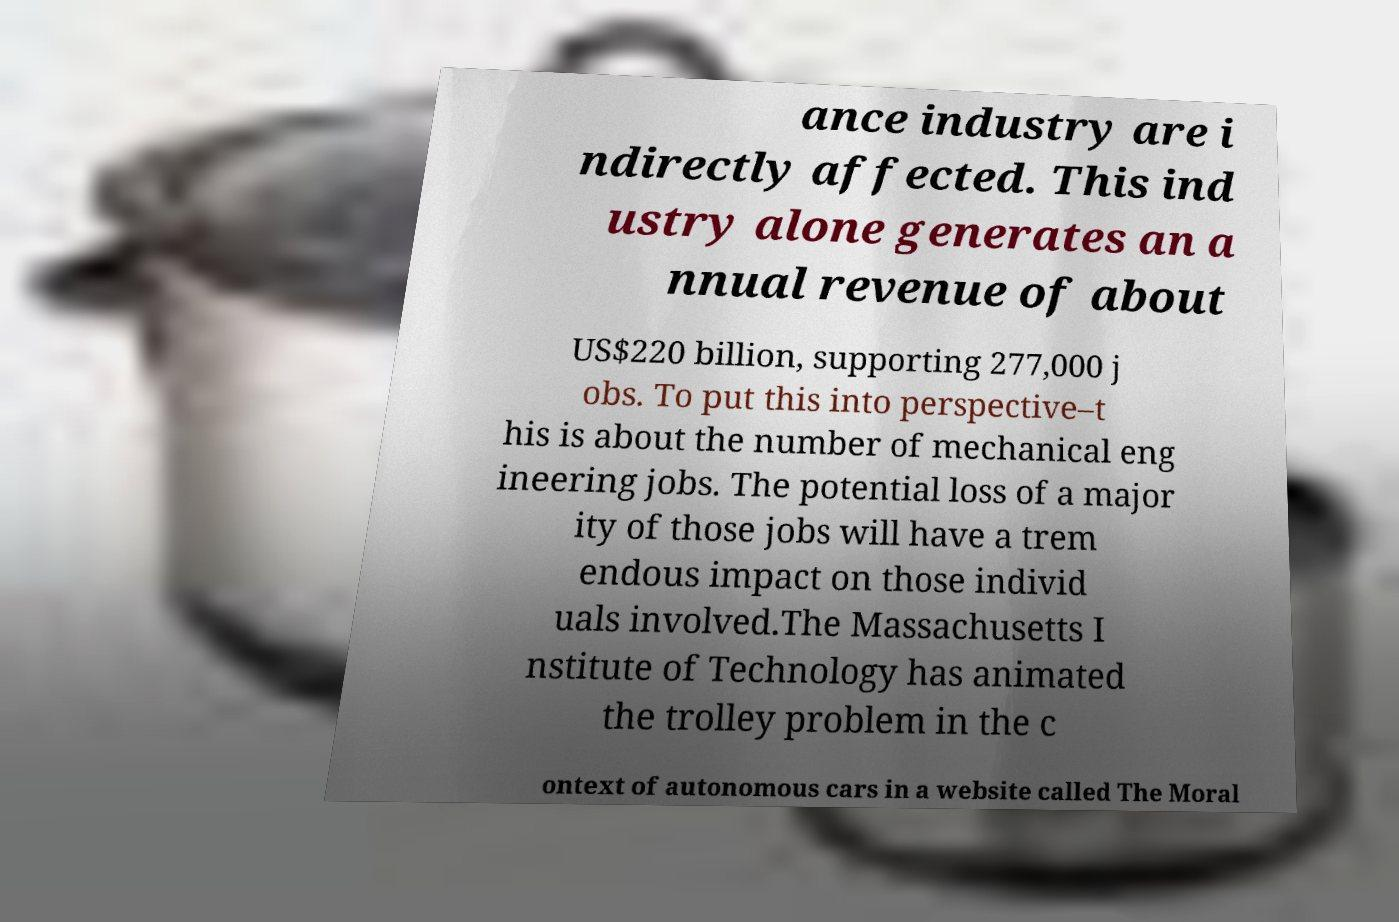Can you accurately transcribe the text from the provided image for me? ance industry are i ndirectly affected. This ind ustry alone generates an a nnual revenue of about US$220 billion, supporting 277,000 j obs. To put this into perspective–t his is about the number of mechanical eng ineering jobs. The potential loss of a major ity of those jobs will have a trem endous impact on those individ uals involved.The Massachusetts I nstitute of Technology has animated the trolley problem in the c ontext of autonomous cars in a website called The Moral 